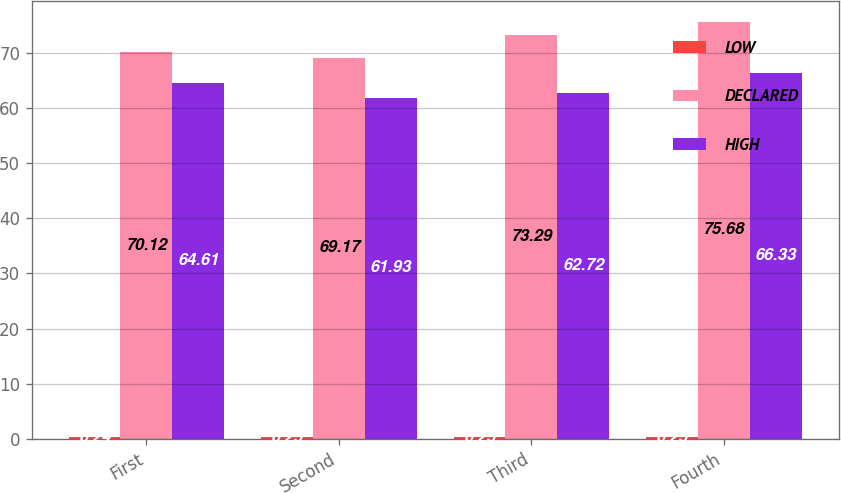<chart> <loc_0><loc_0><loc_500><loc_500><stacked_bar_chart><ecel><fcel>First<fcel>Second<fcel>Third<fcel>Fourth<nl><fcel>LOW<fcel>0.24<fcel>0.25<fcel>0.25<fcel>0.25<nl><fcel>DECLARED<fcel>70.12<fcel>69.17<fcel>73.29<fcel>75.68<nl><fcel>HIGH<fcel>64.61<fcel>61.93<fcel>62.72<fcel>66.33<nl></chart> 